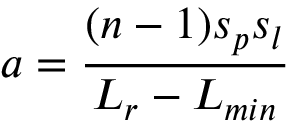Convert formula to latex. <formula><loc_0><loc_0><loc_500><loc_500>a = \frac { ( n - 1 ) s _ { p } s _ { l } } { L _ { r } - L _ { \min } }</formula> 